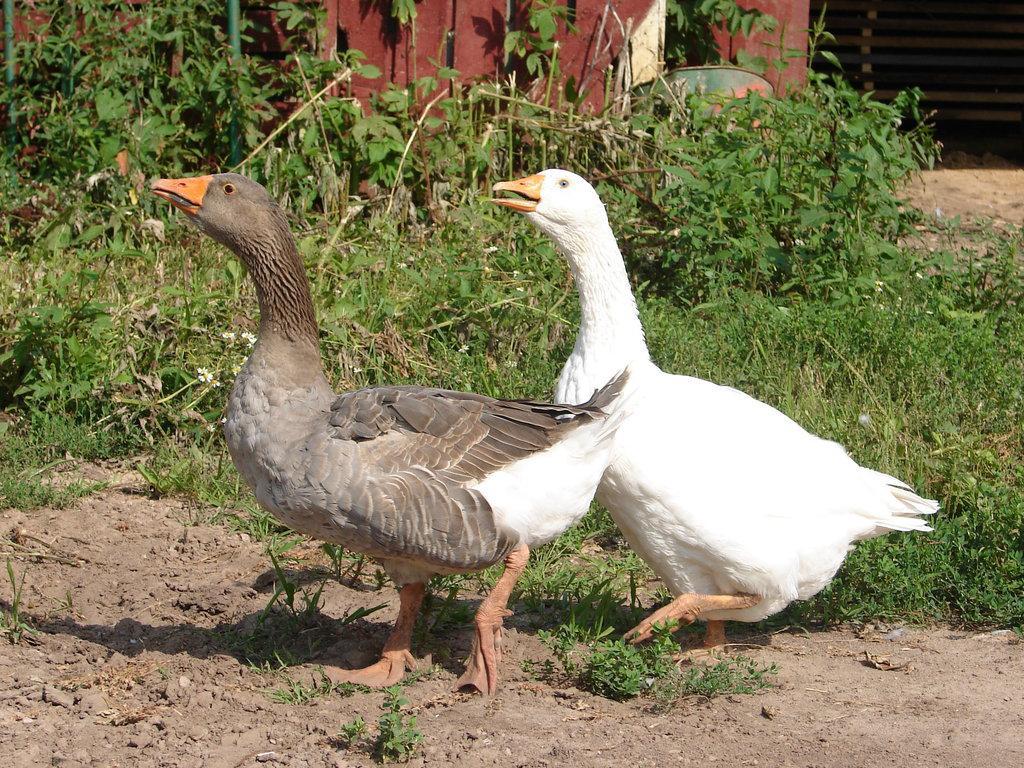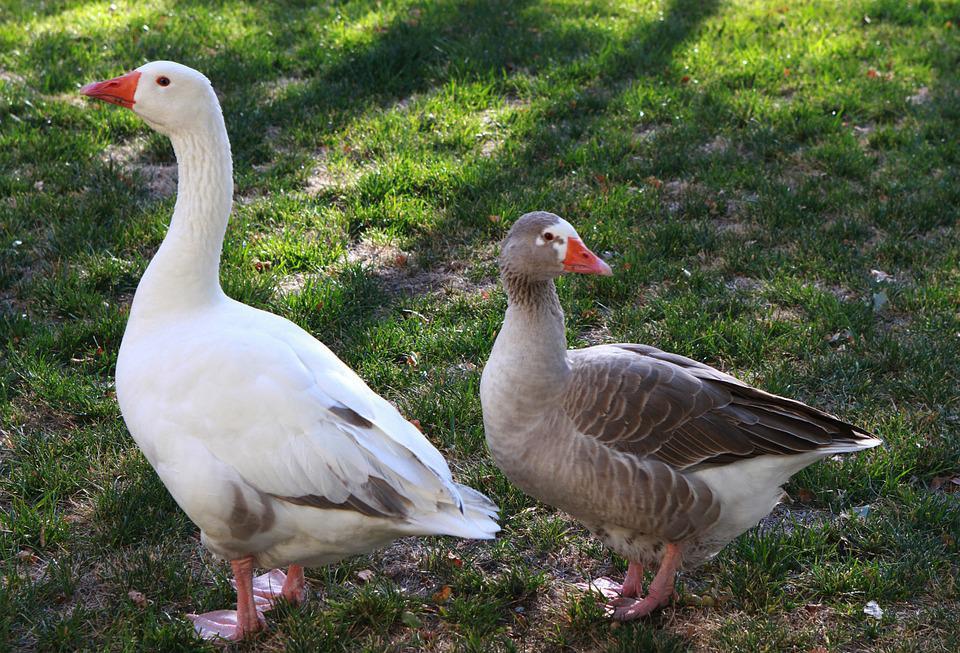The first image is the image on the left, the second image is the image on the right. Assess this claim about the two images: "The right image does not depict more geese than the left image.". Correct or not? Answer yes or no. Yes. 